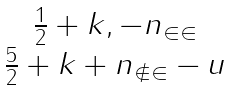<formula> <loc_0><loc_0><loc_500><loc_500>\begin{matrix} \frac { 1 } { 2 } + k , - n _ { \in \in } \\ \frac { 5 } { 2 } + k + n _ { \notin \in } - u \end{matrix}</formula> 